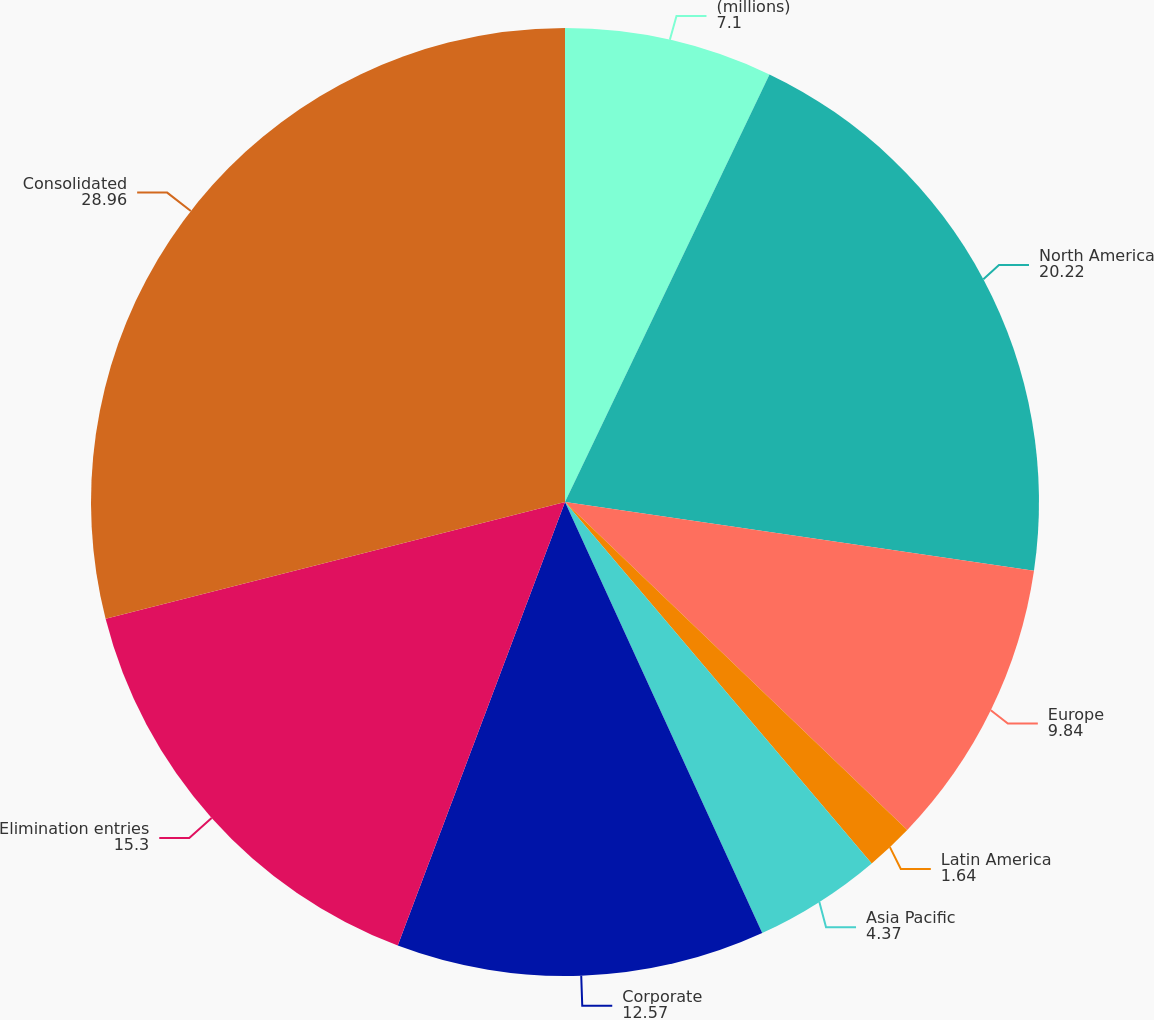Convert chart. <chart><loc_0><loc_0><loc_500><loc_500><pie_chart><fcel>(millions)<fcel>North America<fcel>Europe<fcel>Latin America<fcel>Asia Pacific<fcel>Corporate<fcel>Elimination entries<fcel>Consolidated<nl><fcel>7.1%<fcel>20.22%<fcel>9.84%<fcel>1.64%<fcel>4.37%<fcel>12.57%<fcel>15.3%<fcel>28.96%<nl></chart> 